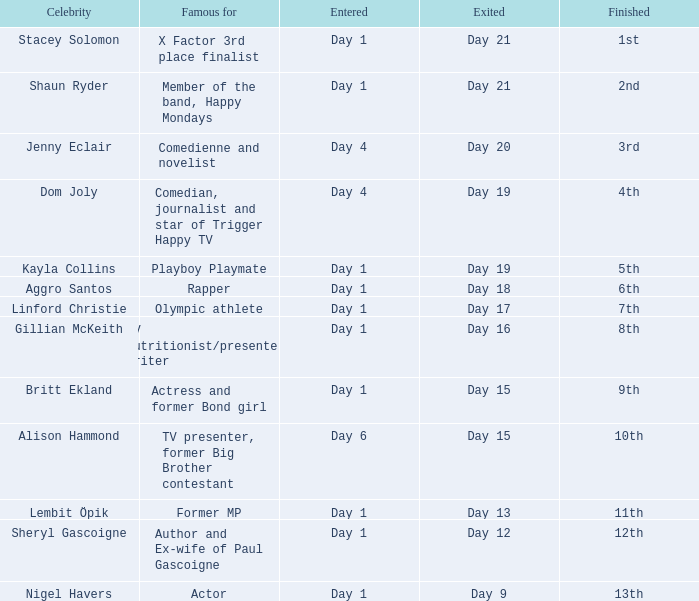What was Dom Joly famous for? Comedian, journalist and star of Trigger Happy TV. 